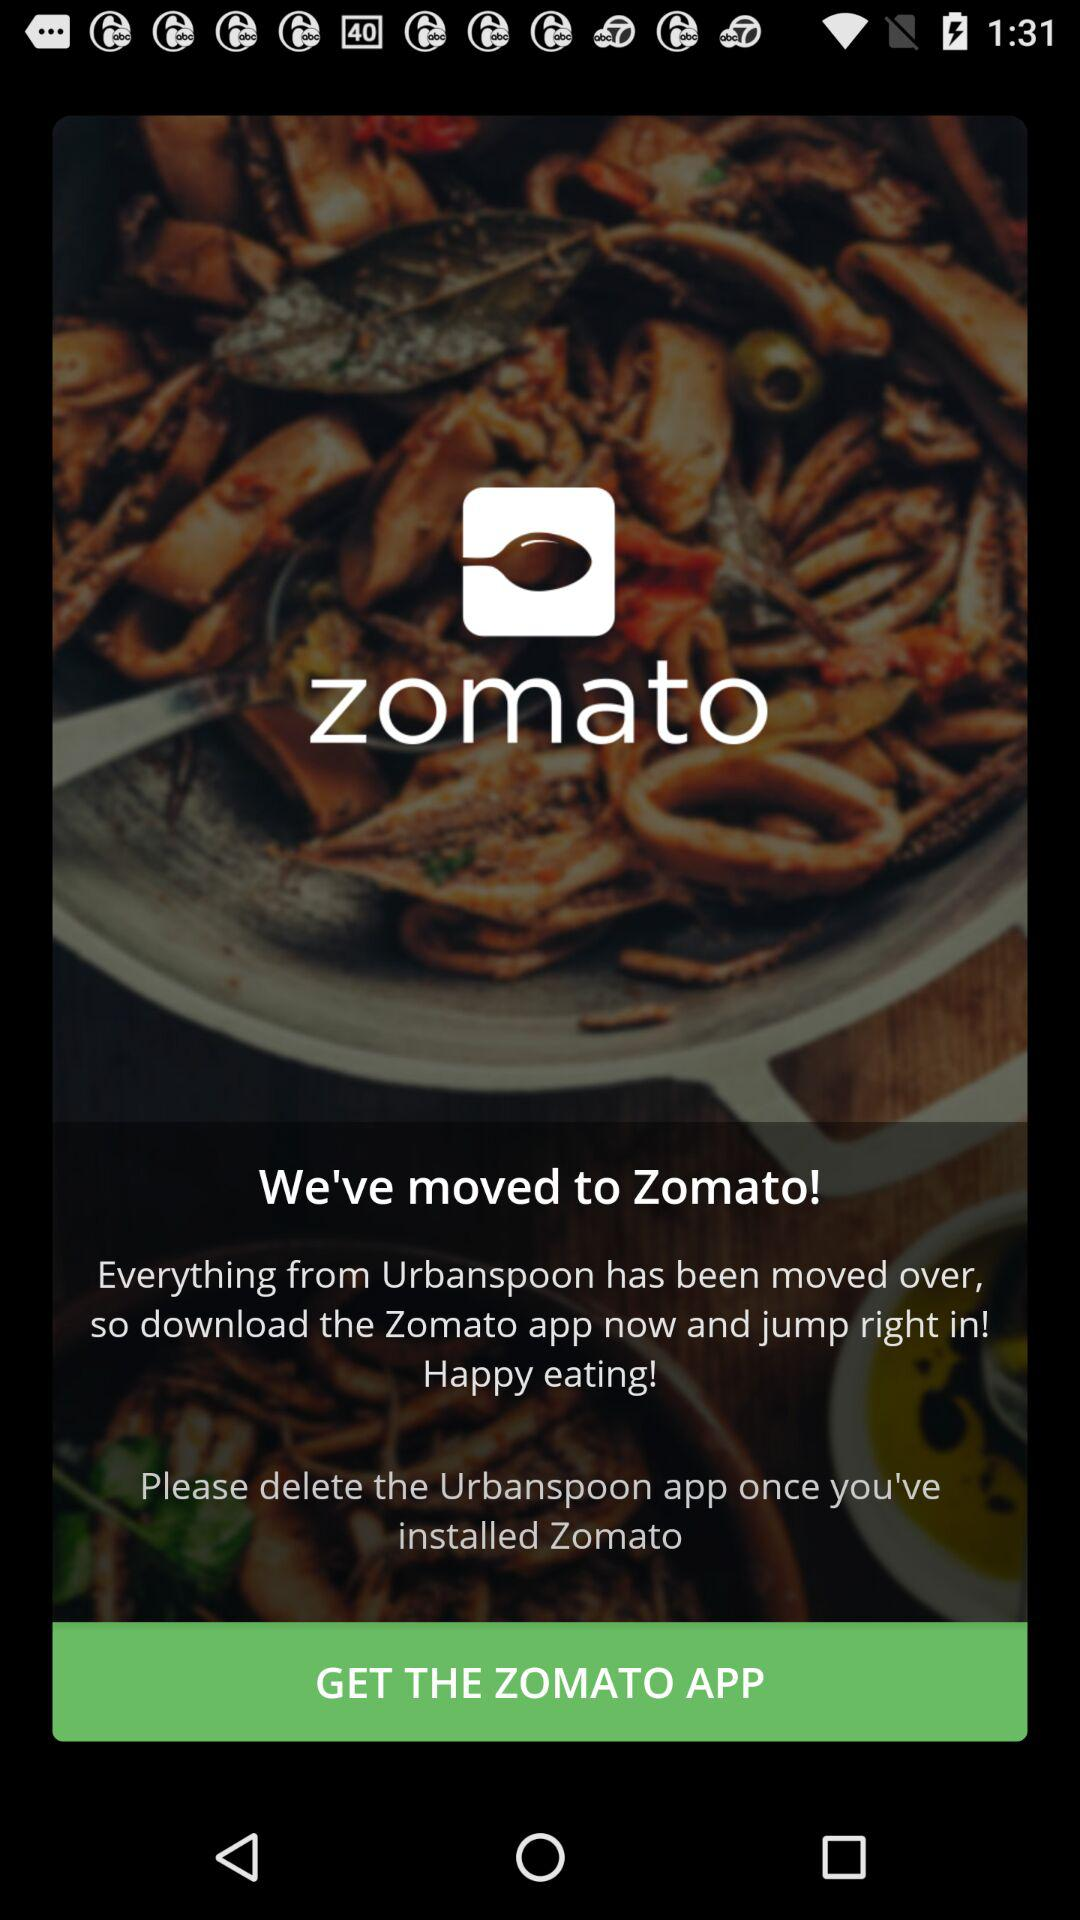What is the app name? The app name is "zomato". 